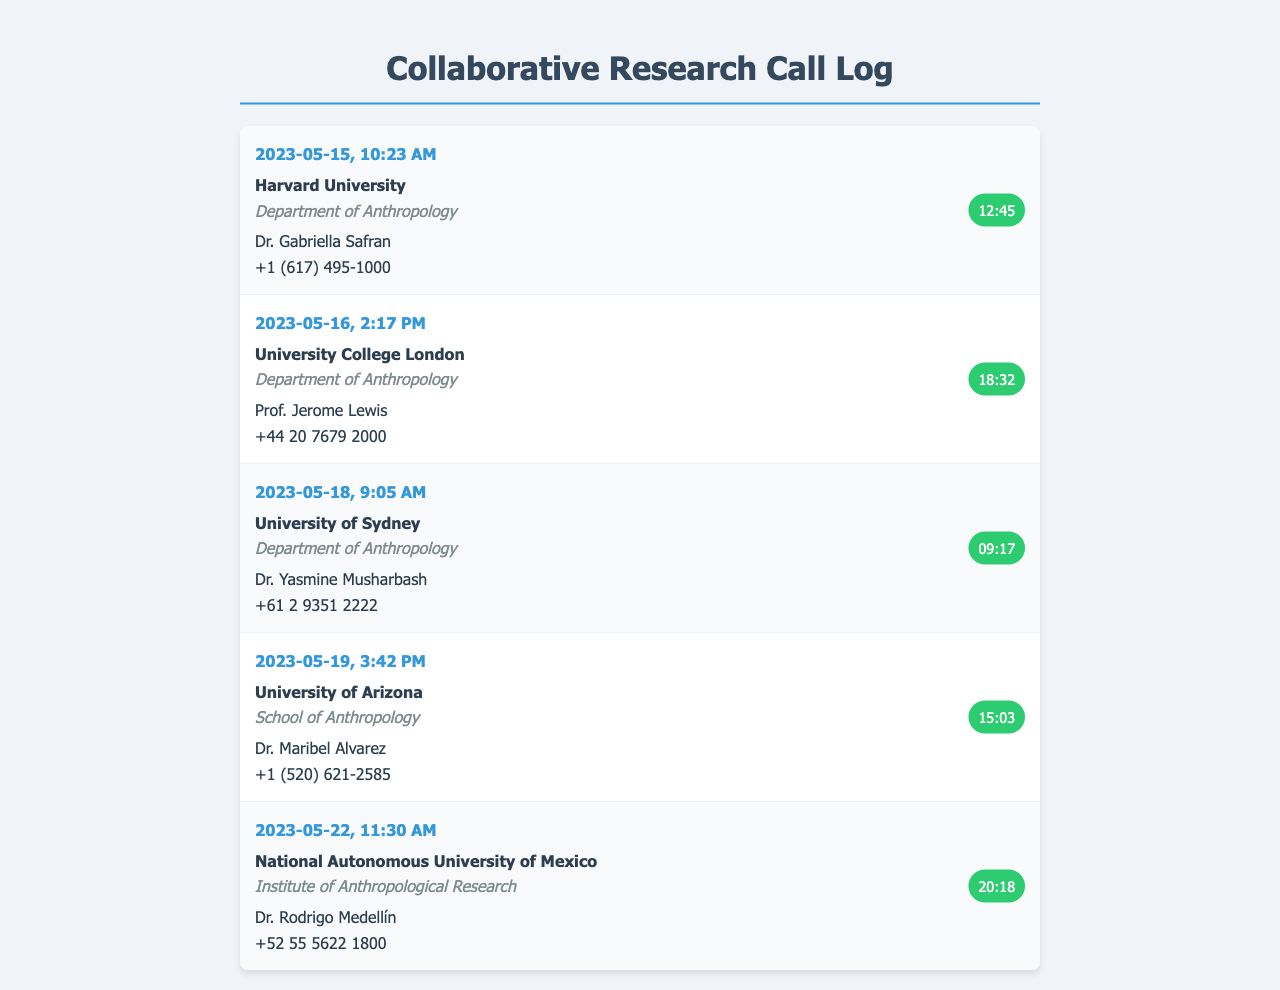what is the date of the call to Harvard University? The date of the call is mentioned in the document as "2023-05-15."
Answer: 2023-05-15 who is the contact at the University College London? The document provides the contact name for University College London as "Prof. Jerome Lewis."
Answer: Prof. Jerome Lewis how long was the call to the University of Sydney? The duration of the call to the University of Sydney is specified as "09:17."
Answer: 09:17 which institution was called on May 22, 2023? The document lists the institution called on this date as "National Autonomous University of Mexico."
Answer: National Autonomous University of Mexico what is the total number of calls listed in the document? The document includes five distinct call entries, indicating the total number of calls made.
Answer: 5 which department is associated with Dr. Maribel Alvarez? The document states that Dr. Maribel Alvarez is associated with the "School of Anthropology."
Answer: School of Anthropology what type of research opportunities are being sought by the calls? The calls aim to discuss "collaborative research opportunities," as stated in the title of the document.
Answer: collaborative research opportunities how many calls were made in the afternoon? The calls to University of Arizona and Harvard University were made in the afternoon, indicating that there were two calls made then.
Answer: 2 